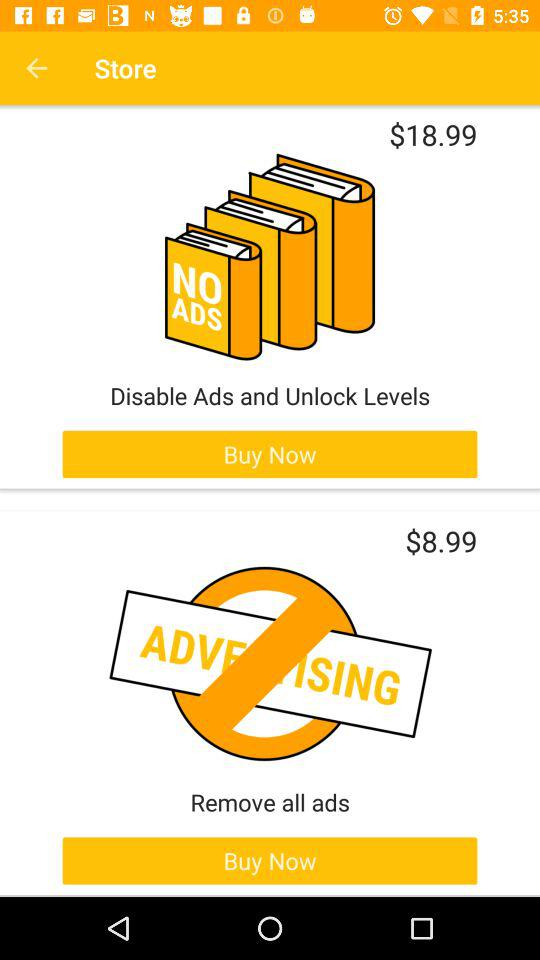How much more does it cost to remove all ads than to disable ads and unlock levels?
Answer the question using a single word or phrase. $10.00 